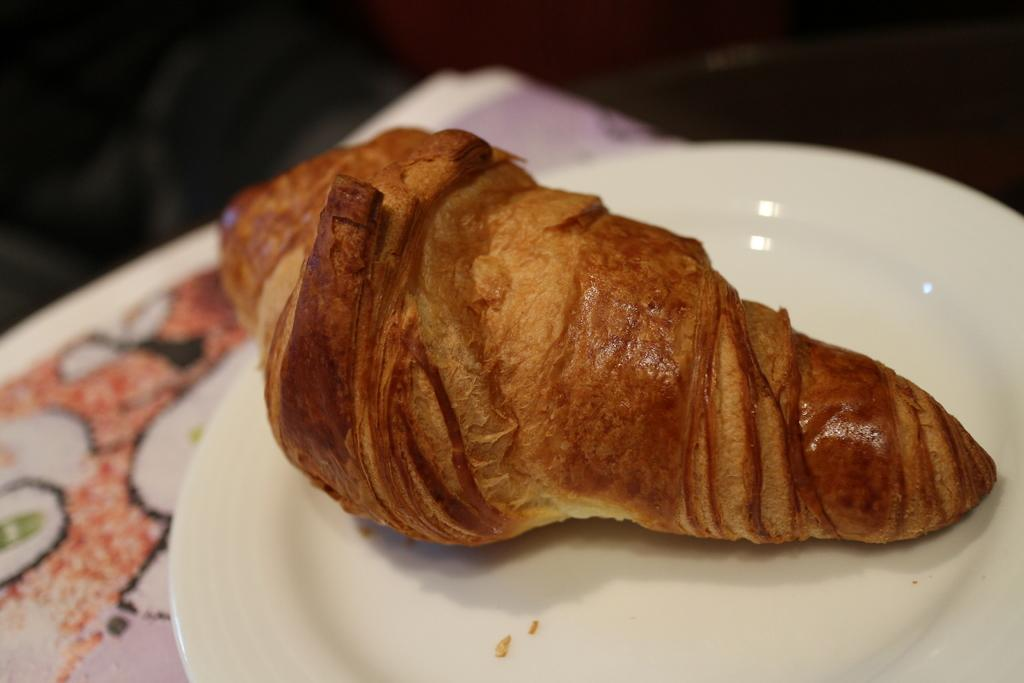What is on the plate in the image? There is a plate with food items in the image. Can you see a robin swimming near the edge of the plate in the image? There is no robin or swimming activity present in the image; it features a plate with food items. 